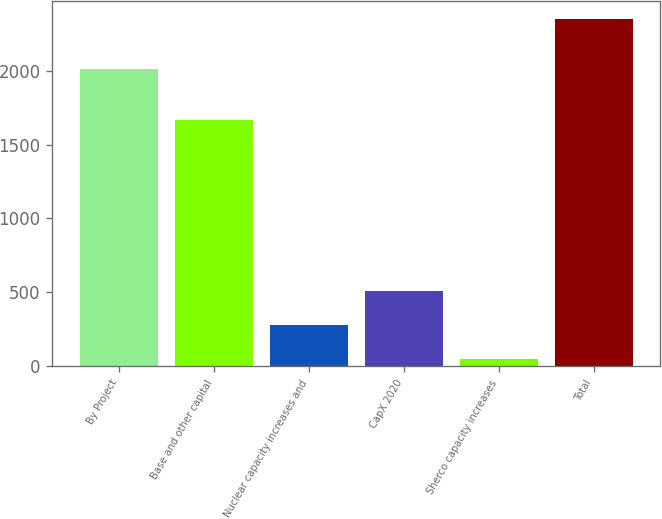Convert chart. <chart><loc_0><loc_0><loc_500><loc_500><bar_chart><fcel>By Project<fcel>Base and other capital<fcel>Nuclear capacity increases and<fcel>CapX 2020<fcel>Sherco capacity increases<fcel>Total<nl><fcel>2012<fcel>1665<fcel>280<fcel>510<fcel>50<fcel>2350<nl></chart> 